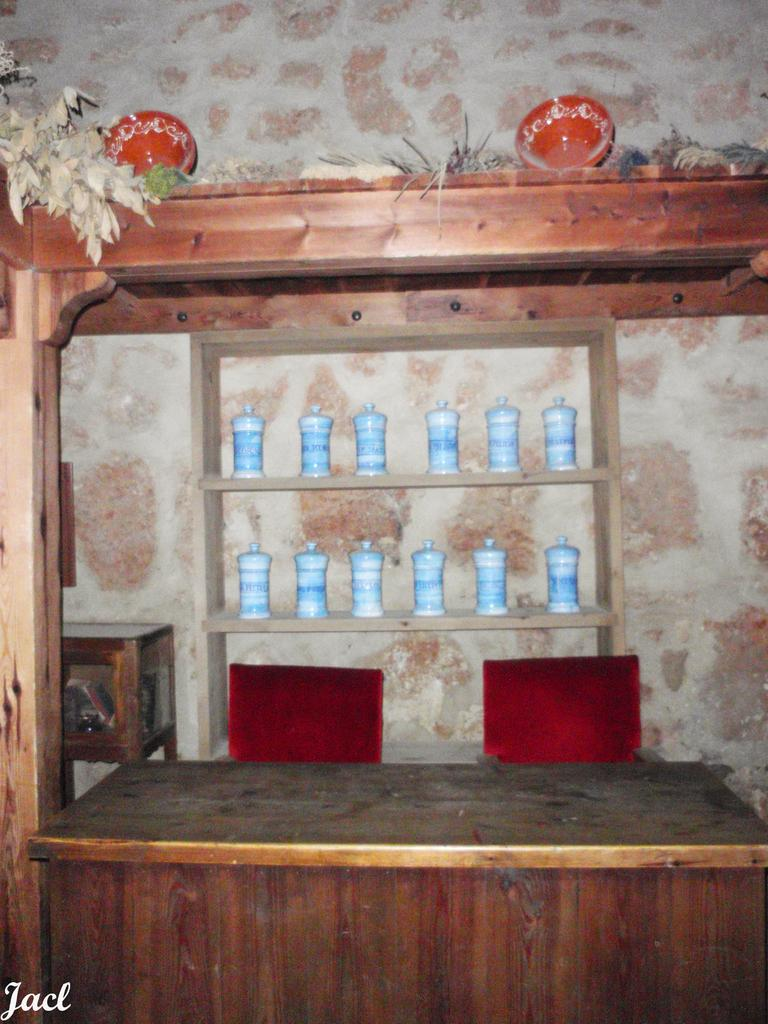What type of furniture is present in the image? There is a table and chairs in the image. What can be seen on or around the table? Decorations and glass jars are visible in the image. How are the glass jars arranged? The glass jars are arranged in racks. What type of brake system can be seen on the road in the image? There is no road or brake system present in the image. Can you tell me how many baseballs are on the table in the image? There are no baseballs present in the image. 